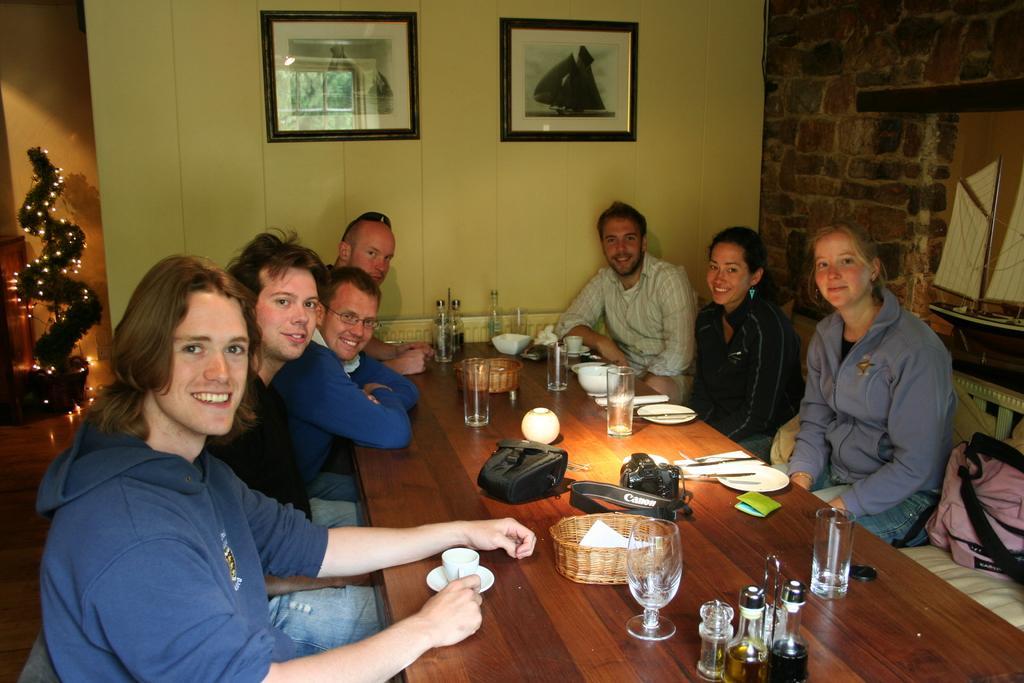Describe this image in one or two sentences. Here we can see a group of people sitting on benches with table in front of them having glasses and plates and many other things present on it and behind them on the wall we can see portraits present and at the left side we can see a tree decorated with lights 